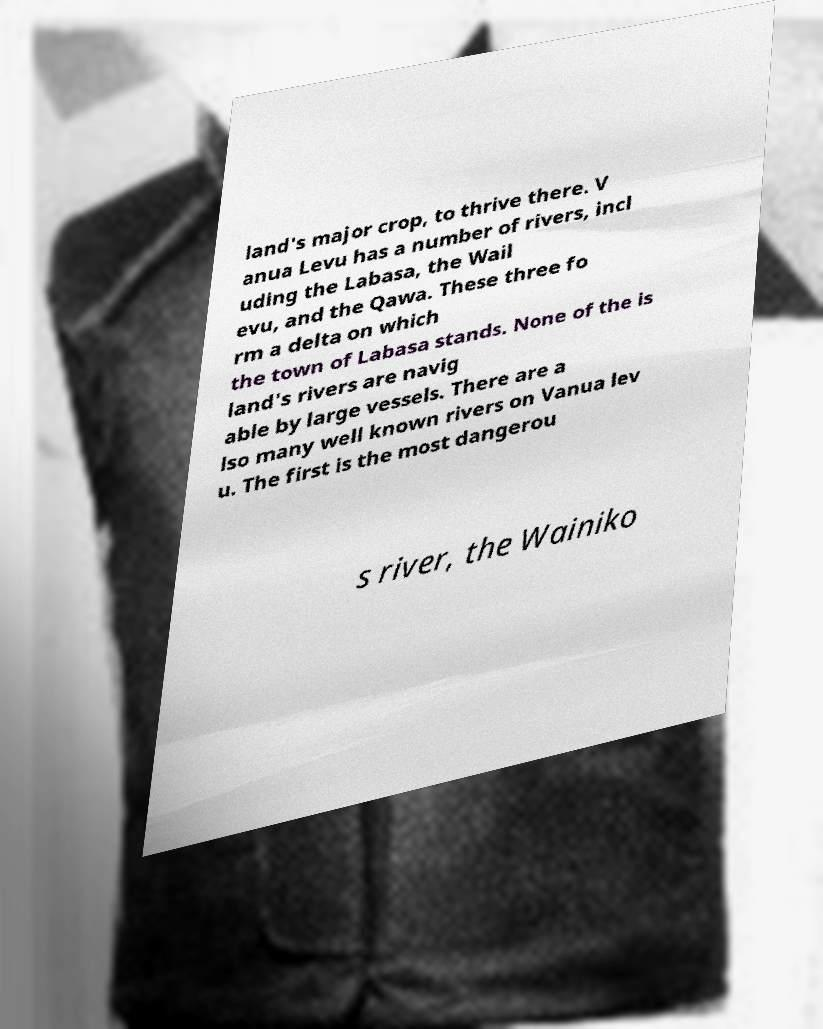I need the written content from this picture converted into text. Can you do that? land's major crop, to thrive there. V anua Levu has a number of rivers, incl uding the Labasa, the Wail evu, and the Qawa. These three fo rm a delta on which the town of Labasa stands. None of the is land's rivers are navig able by large vessels. There are a lso many well known rivers on Vanua lev u. The first is the most dangerou s river, the Wainiko 